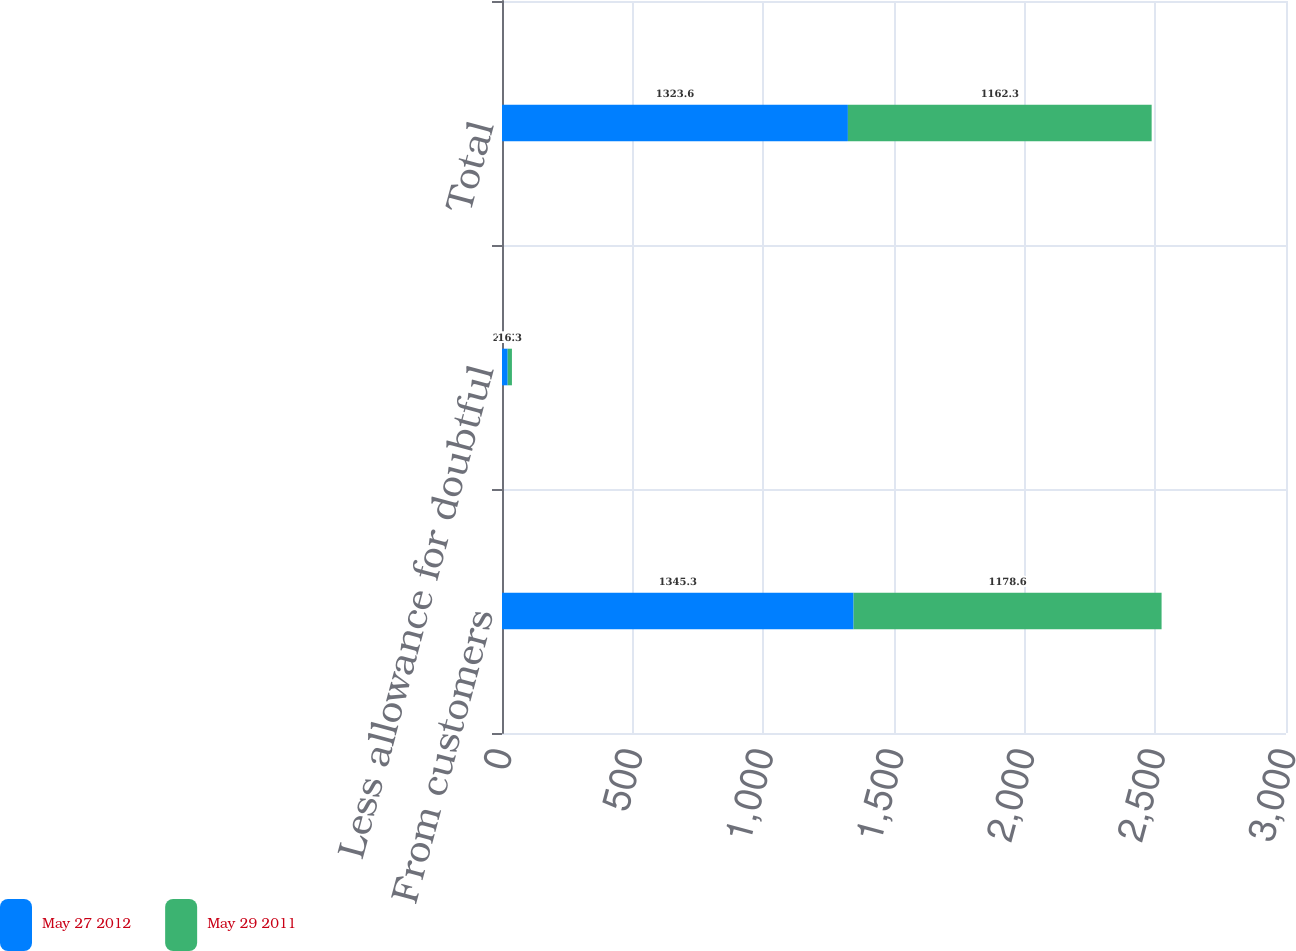Convert chart. <chart><loc_0><loc_0><loc_500><loc_500><stacked_bar_chart><ecel><fcel>From customers<fcel>Less allowance for doubtful<fcel>Total<nl><fcel>May 27 2012<fcel>1345.3<fcel>21.7<fcel>1323.6<nl><fcel>May 29 2011<fcel>1178.6<fcel>16.3<fcel>1162.3<nl></chart> 